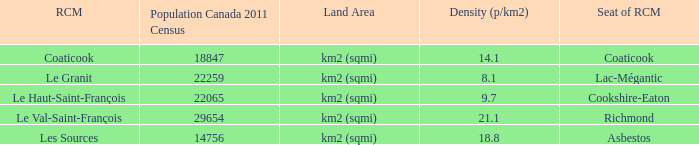What is the land area of the RCM having a density of 21.1? Km2 (sqmi). 